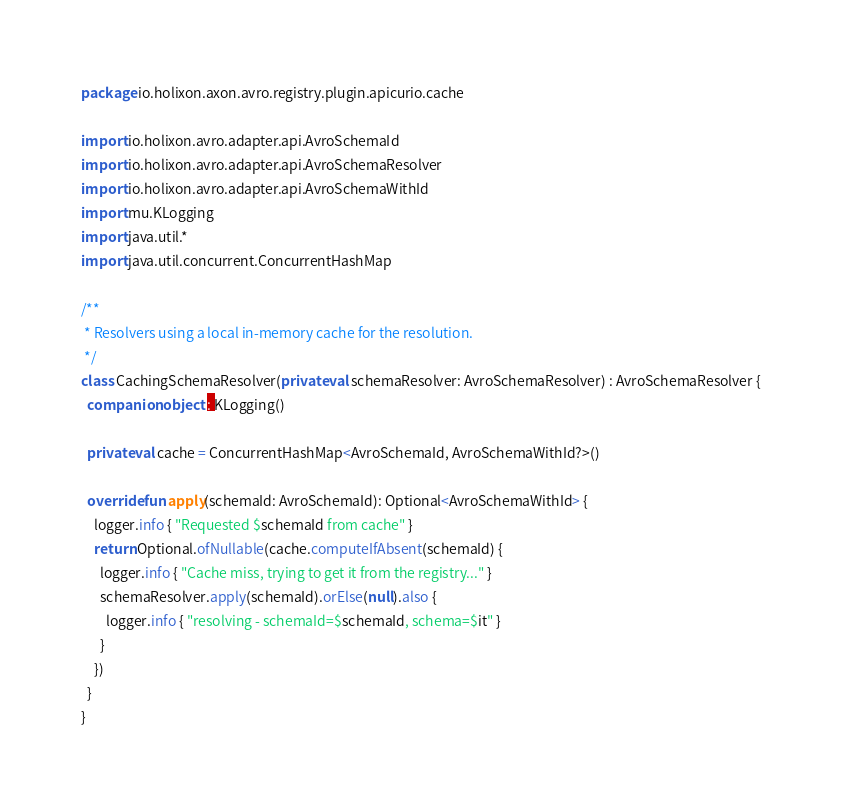Convert code to text. <code><loc_0><loc_0><loc_500><loc_500><_Kotlin_>package io.holixon.axon.avro.registry.plugin.apicurio.cache

import io.holixon.avro.adapter.api.AvroSchemaId
import io.holixon.avro.adapter.api.AvroSchemaResolver
import io.holixon.avro.adapter.api.AvroSchemaWithId
import mu.KLogging
import java.util.*
import java.util.concurrent.ConcurrentHashMap

/**
 * Resolvers using a local in-memory cache for the resolution.
 */
class CachingSchemaResolver(private val schemaResolver: AvroSchemaResolver) : AvroSchemaResolver {
  companion object : KLogging()

  private val cache = ConcurrentHashMap<AvroSchemaId, AvroSchemaWithId?>()

  override fun apply(schemaId: AvroSchemaId): Optional<AvroSchemaWithId> {
    logger.info { "Requested $schemaId from cache" }
    return Optional.ofNullable(cache.computeIfAbsent(schemaId) {
      logger.info { "Cache miss, trying to get it from the registry..." }
      schemaResolver.apply(schemaId).orElse(null).also {
        logger.info { "resolving - schemaId=$schemaId, schema=$it" }
      }
    })
  }
}
</code> 